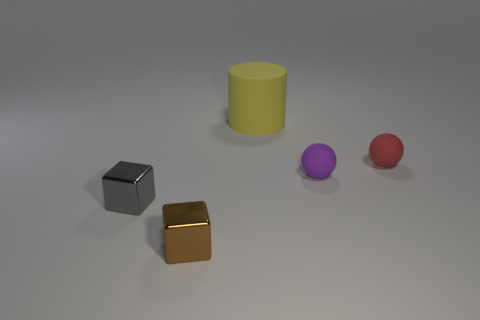There is a thing that is left of the yellow matte object and behind the brown block; what is its material?
Your answer should be compact. Metal. The metal thing that is in front of the gray cube has what shape?
Offer a terse response. Cube. What is the shape of the tiny metal object that is to the left of the tiny thing in front of the gray metallic block?
Your answer should be very brief. Cube. Is there another tiny metallic thing of the same shape as the small gray object?
Your response must be concise. Yes. The gray metallic thing that is the same size as the red ball is what shape?
Keep it short and to the point. Cube. There is a small sphere that is behind the small matte object that is in front of the small red matte sphere; are there any balls that are to the left of it?
Give a very brief answer. Yes. Is there a metal object of the same size as the red matte object?
Your answer should be very brief. Yes. How big is the metal block that is to the left of the brown shiny thing?
Offer a terse response. Small. What is the color of the tiny object that is to the right of the tiny matte ball in front of the tiny sphere on the right side of the purple object?
Your answer should be very brief. Red. What is the color of the rubber thing that is in front of the small ball that is on the right side of the tiny purple sphere?
Provide a succinct answer. Purple. 